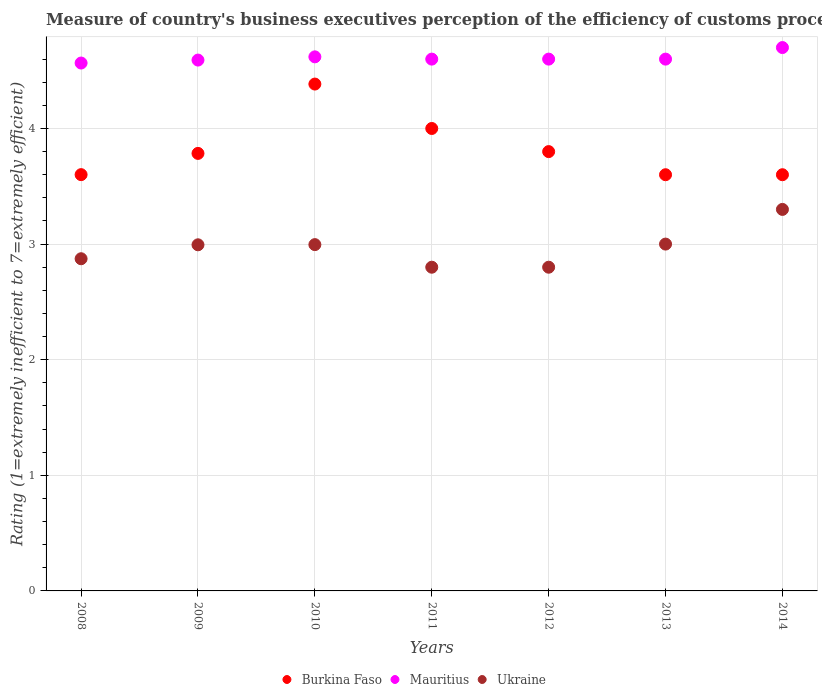Is the number of dotlines equal to the number of legend labels?
Your answer should be compact. Yes. Across all years, what is the maximum rating of the efficiency of customs procedure in Mauritius?
Your response must be concise. 4.7. In which year was the rating of the efficiency of customs procedure in Ukraine maximum?
Give a very brief answer. 2014. What is the total rating of the efficiency of customs procedure in Burkina Faso in the graph?
Offer a very short reply. 26.77. What is the difference between the rating of the efficiency of customs procedure in Mauritius in 2009 and that in 2012?
Keep it short and to the point. -0.01. What is the difference between the rating of the efficiency of customs procedure in Mauritius in 2011 and the rating of the efficiency of customs procedure in Ukraine in 2012?
Your answer should be compact. 1.8. What is the average rating of the efficiency of customs procedure in Ukraine per year?
Give a very brief answer. 2.97. In the year 2009, what is the difference between the rating of the efficiency of customs procedure in Mauritius and rating of the efficiency of customs procedure in Ukraine?
Provide a succinct answer. 1.6. What is the ratio of the rating of the efficiency of customs procedure in Ukraine in 2008 to that in 2014?
Your answer should be very brief. 0.87. What is the difference between the highest and the second highest rating of the efficiency of customs procedure in Burkina Faso?
Your answer should be very brief. 0.38. What is the difference between the highest and the lowest rating of the efficiency of customs procedure in Ukraine?
Give a very brief answer. 0.5. In how many years, is the rating of the efficiency of customs procedure in Burkina Faso greater than the average rating of the efficiency of customs procedure in Burkina Faso taken over all years?
Provide a short and direct response. 2. Is the rating of the efficiency of customs procedure in Ukraine strictly greater than the rating of the efficiency of customs procedure in Mauritius over the years?
Your answer should be compact. No. Is the rating of the efficiency of customs procedure in Ukraine strictly less than the rating of the efficiency of customs procedure in Mauritius over the years?
Your answer should be very brief. Yes. How many dotlines are there?
Make the answer very short. 3. How many years are there in the graph?
Offer a very short reply. 7. What is the difference between two consecutive major ticks on the Y-axis?
Offer a terse response. 1. Where does the legend appear in the graph?
Offer a very short reply. Bottom center. How many legend labels are there?
Offer a very short reply. 3. What is the title of the graph?
Give a very brief answer. Measure of country's business executives perception of the efficiency of customs procedures. Does "Pakistan" appear as one of the legend labels in the graph?
Provide a succinct answer. No. What is the label or title of the X-axis?
Ensure brevity in your answer.  Years. What is the label or title of the Y-axis?
Ensure brevity in your answer.  Rating (1=extremely inefficient to 7=extremely efficient). What is the Rating (1=extremely inefficient to 7=extremely efficient) of Burkina Faso in 2008?
Offer a very short reply. 3.6. What is the Rating (1=extremely inefficient to 7=extremely efficient) of Mauritius in 2008?
Your answer should be very brief. 4.57. What is the Rating (1=extremely inefficient to 7=extremely efficient) of Ukraine in 2008?
Provide a succinct answer. 2.87. What is the Rating (1=extremely inefficient to 7=extremely efficient) of Burkina Faso in 2009?
Your answer should be very brief. 3.78. What is the Rating (1=extremely inefficient to 7=extremely efficient) of Mauritius in 2009?
Your response must be concise. 4.59. What is the Rating (1=extremely inefficient to 7=extremely efficient) in Ukraine in 2009?
Your answer should be very brief. 2.99. What is the Rating (1=extremely inefficient to 7=extremely efficient) in Burkina Faso in 2010?
Offer a very short reply. 4.38. What is the Rating (1=extremely inefficient to 7=extremely efficient) in Mauritius in 2010?
Offer a very short reply. 4.62. What is the Rating (1=extremely inefficient to 7=extremely efficient) of Ukraine in 2010?
Provide a short and direct response. 3. What is the Rating (1=extremely inefficient to 7=extremely efficient) in Mauritius in 2011?
Give a very brief answer. 4.6. What is the Rating (1=extremely inefficient to 7=extremely efficient) in Ukraine in 2011?
Your response must be concise. 2.8. What is the Rating (1=extremely inefficient to 7=extremely efficient) of Mauritius in 2013?
Ensure brevity in your answer.  4.6. What is the Rating (1=extremely inefficient to 7=extremely efficient) in Burkina Faso in 2014?
Make the answer very short. 3.6. What is the Rating (1=extremely inefficient to 7=extremely efficient) of Mauritius in 2014?
Give a very brief answer. 4.7. Across all years, what is the maximum Rating (1=extremely inefficient to 7=extremely efficient) of Burkina Faso?
Your response must be concise. 4.38. Across all years, what is the maximum Rating (1=extremely inefficient to 7=extremely efficient) of Mauritius?
Provide a short and direct response. 4.7. Across all years, what is the maximum Rating (1=extremely inefficient to 7=extremely efficient) of Ukraine?
Ensure brevity in your answer.  3.3. Across all years, what is the minimum Rating (1=extremely inefficient to 7=extremely efficient) in Mauritius?
Provide a short and direct response. 4.57. Across all years, what is the minimum Rating (1=extremely inefficient to 7=extremely efficient) in Ukraine?
Keep it short and to the point. 2.8. What is the total Rating (1=extremely inefficient to 7=extremely efficient) of Burkina Faso in the graph?
Your answer should be very brief. 26.77. What is the total Rating (1=extremely inefficient to 7=extremely efficient) of Mauritius in the graph?
Ensure brevity in your answer.  32.28. What is the total Rating (1=extremely inefficient to 7=extremely efficient) in Ukraine in the graph?
Keep it short and to the point. 20.76. What is the difference between the Rating (1=extremely inefficient to 7=extremely efficient) of Burkina Faso in 2008 and that in 2009?
Provide a short and direct response. -0.18. What is the difference between the Rating (1=extremely inefficient to 7=extremely efficient) of Mauritius in 2008 and that in 2009?
Your answer should be compact. -0.03. What is the difference between the Rating (1=extremely inefficient to 7=extremely efficient) in Ukraine in 2008 and that in 2009?
Your response must be concise. -0.12. What is the difference between the Rating (1=extremely inefficient to 7=extremely efficient) of Burkina Faso in 2008 and that in 2010?
Your response must be concise. -0.78. What is the difference between the Rating (1=extremely inefficient to 7=extremely efficient) in Mauritius in 2008 and that in 2010?
Ensure brevity in your answer.  -0.05. What is the difference between the Rating (1=extremely inefficient to 7=extremely efficient) of Ukraine in 2008 and that in 2010?
Give a very brief answer. -0.12. What is the difference between the Rating (1=extremely inefficient to 7=extremely efficient) of Burkina Faso in 2008 and that in 2011?
Provide a succinct answer. -0.4. What is the difference between the Rating (1=extremely inefficient to 7=extremely efficient) in Mauritius in 2008 and that in 2011?
Keep it short and to the point. -0.03. What is the difference between the Rating (1=extremely inefficient to 7=extremely efficient) in Ukraine in 2008 and that in 2011?
Provide a succinct answer. 0.07. What is the difference between the Rating (1=extremely inefficient to 7=extremely efficient) of Burkina Faso in 2008 and that in 2012?
Offer a very short reply. -0.2. What is the difference between the Rating (1=extremely inefficient to 7=extremely efficient) of Mauritius in 2008 and that in 2012?
Offer a terse response. -0.03. What is the difference between the Rating (1=extremely inefficient to 7=extremely efficient) of Ukraine in 2008 and that in 2012?
Your response must be concise. 0.07. What is the difference between the Rating (1=extremely inefficient to 7=extremely efficient) of Burkina Faso in 2008 and that in 2013?
Your answer should be compact. 0. What is the difference between the Rating (1=extremely inefficient to 7=extremely efficient) of Mauritius in 2008 and that in 2013?
Keep it short and to the point. -0.03. What is the difference between the Rating (1=extremely inefficient to 7=extremely efficient) in Ukraine in 2008 and that in 2013?
Your answer should be compact. -0.13. What is the difference between the Rating (1=extremely inefficient to 7=extremely efficient) of Burkina Faso in 2008 and that in 2014?
Your answer should be compact. 0. What is the difference between the Rating (1=extremely inefficient to 7=extremely efficient) of Mauritius in 2008 and that in 2014?
Provide a short and direct response. -0.13. What is the difference between the Rating (1=extremely inefficient to 7=extremely efficient) of Ukraine in 2008 and that in 2014?
Your answer should be very brief. -0.43. What is the difference between the Rating (1=extremely inefficient to 7=extremely efficient) in Burkina Faso in 2009 and that in 2010?
Your response must be concise. -0.6. What is the difference between the Rating (1=extremely inefficient to 7=extremely efficient) of Mauritius in 2009 and that in 2010?
Your answer should be compact. -0.03. What is the difference between the Rating (1=extremely inefficient to 7=extremely efficient) of Ukraine in 2009 and that in 2010?
Ensure brevity in your answer.  -0. What is the difference between the Rating (1=extremely inefficient to 7=extremely efficient) of Burkina Faso in 2009 and that in 2011?
Your response must be concise. -0.22. What is the difference between the Rating (1=extremely inefficient to 7=extremely efficient) in Mauritius in 2009 and that in 2011?
Give a very brief answer. -0.01. What is the difference between the Rating (1=extremely inefficient to 7=extremely efficient) in Ukraine in 2009 and that in 2011?
Your response must be concise. 0.19. What is the difference between the Rating (1=extremely inefficient to 7=extremely efficient) in Burkina Faso in 2009 and that in 2012?
Keep it short and to the point. -0.02. What is the difference between the Rating (1=extremely inefficient to 7=extremely efficient) of Mauritius in 2009 and that in 2012?
Offer a terse response. -0.01. What is the difference between the Rating (1=extremely inefficient to 7=extremely efficient) of Ukraine in 2009 and that in 2012?
Offer a terse response. 0.19. What is the difference between the Rating (1=extremely inefficient to 7=extremely efficient) of Burkina Faso in 2009 and that in 2013?
Ensure brevity in your answer.  0.18. What is the difference between the Rating (1=extremely inefficient to 7=extremely efficient) in Mauritius in 2009 and that in 2013?
Provide a succinct answer. -0.01. What is the difference between the Rating (1=extremely inefficient to 7=extremely efficient) in Ukraine in 2009 and that in 2013?
Your response must be concise. -0.01. What is the difference between the Rating (1=extremely inefficient to 7=extremely efficient) of Burkina Faso in 2009 and that in 2014?
Offer a very short reply. 0.18. What is the difference between the Rating (1=extremely inefficient to 7=extremely efficient) of Mauritius in 2009 and that in 2014?
Your answer should be very brief. -0.11. What is the difference between the Rating (1=extremely inefficient to 7=extremely efficient) of Ukraine in 2009 and that in 2014?
Provide a succinct answer. -0.31. What is the difference between the Rating (1=extremely inefficient to 7=extremely efficient) of Burkina Faso in 2010 and that in 2011?
Offer a terse response. 0.38. What is the difference between the Rating (1=extremely inefficient to 7=extremely efficient) in Mauritius in 2010 and that in 2011?
Your response must be concise. 0.02. What is the difference between the Rating (1=extremely inefficient to 7=extremely efficient) in Ukraine in 2010 and that in 2011?
Keep it short and to the point. 0.2. What is the difference between the Rating (1=extremely inefficient to 7=extremely efficient) in Burkina Faso in 2010 and that in 2012?
Your response must be concise. 0.58. What is the difference between the Rating (1=extremely inefficient to 7=extremely efficient) in Mauritius in 2010 and that in 2012?
Keep it short and to the point. 0.02. What is the difference between the Rating (1=extremely inefficient to 7=extremely efficient) of Ukraine in 2010 and that in 2012?
Make the answer very short. 0.2. What is the difference between the Rating (1=extremely inefficient to 7=extremely efficient) in Burkina Faso in 2010 and that in 2013?
Provide a short and direct response. 0.78. What is the difference between the Rating (1=extremely inefficient to 7=extremely efficient) in Mauritius in 2010 and that in 2013?
Make the answer very short. 0.02. What is the difference between the Rating (1=extremely inefficient to 7=extremely efficient) of Ukraine in 2010 and that in 2013?
Offer a terse response. -0. What is the difference between the Rating (1=extremely inefficient to 7=extremely efficient) of Burkina Faso in 2010 and that in 2014?
Provide a short and direct response. 0.78. What is the difference between the Rating (1=extremely inefficient to 7=extremely efficient) of Mauritius in 2010 and that in 2014?
Provide a succinct answer. -0.08. What is the difference between the Rating (1=extremely inefficient to 7=extremely efficient) of Ukraine in 2010 and that in 2014?
Keep it short and to the point. -0.3. What is the difference between the Rating (1=extremely inefficient to 7=extremely efficient) in Mauritius in 2011 and that in 2012?
Your response must be concise. 0. What is the difference between the Rating (1=extremely inefficient to 7=extremely efficient) in Mauritius in 2011 and that in 2013?
Give a very brief answer. 0. What is the difference between the Rating (1=extremely inefficient to 7=extremely efficient) of Burkina Faso in 2012 and that in 2013?
Give a very brief answer. 0.2. What is the difference between the Rating (1=extremely inefficient to 7=extremely efficient) in Mauritius in 2012 and that in 2013?
Make the answer very short. 0. What is the difference between the Rating (1=extremely inefficient to 7=extremely efficient) in Ukraine in 2012 and that in 2013?
Give a very brief answer. -0.2. What is the difference between the Rating (1=extremely inefficient to 7=extremely efficient) in Burkina Faso in 2012 and that in 2014?
Offer a terse response. 0.2. What is the difference between the Rating (1=extremely inefficient to 7=extremely efficient) in Mauritius in 2012 and that in 2014?
Keep it short and to the point. -0.1. What is the difference between the Rating (1=extremely inefficient to 7=extremely efficient) in Burkina Faso in 2013 and that in 2014?
Make the answer very short. 0. What is the difference between the Rating (1=extremely inefficient to 7=extremely efficient) in Mauritius in 2013 and that in 2014?
Your answer should be compact. -0.1. What is the difference between the Rating (1=extremely inefficient to 7=extremely efficient) in Ukraine in 2013 and that in 2014?
Offer a terse response. -0.3. What is the difference between the Rating (1=extremely inefficient to 7=extremely efficient) in Burkina Faso in 2008 and the Rating (1=extremely inefficient to 7=extremely efficient) in Mauritius in 2009?
Provide a short and direct response. -0.99. What is the difference between the Rating (1=extremely inefficient to 7=extremely efficient) in Burkina Faso in 2008 and the Rating (1=extremely inefficient to 7=extremely efficient) in Ukraine in 2009?
Your answer should be very brief. 0.61. What is the difference between the Rating (1=extremely inefficient to 7=extremely efficient) of Mauritius in 2008 and the Rating (1=extremely inefficient to 7=extremely efficient) of Ukraine in 2009?
Offer a terse response. 1.57. What is the difference between the Rating (1=extremely inefficient to 7=extremely efficient) of Burkina Faso in 2008 and the Rating (1=extremely inefficient to 7=extremely efficient) of Mauritius in 2010?
Give a very brief answer. -1.02. What is the difference between the Rating (1=extremely inefficient to 7=extremely efficient) of Burkina Faso in 2008 and the Rating (1=extremely inefficient to 7=extremely efficient) of Ukraine in 2010?
Your response must be concise. 0.61. What is the difference between the Rating (1=extremely inefficient to 7=extremely efficient) of Mauritius in 2008 and the Rating (1=extremely inefficient to 7=extremely efficient) of Ukraine in 2010?
Keep it short and to the point. 1.57. What is the difference between the Rating (1=extremely inefficient to 7=extremely efficient) of Burkina Faso in 2008 and the Rating (1=extremely inefficient to 7=extremely efficient) of Mauritius in 2011?
Keep it short and to the point. -1. What is the difference between the Rating (1=extremely inefficient to 7=extremely efficient) of Burkina Faso in 2008 and the Rating (1=extremely inefficient to 7=extremely efficient) of Ukraine in 2011?
Your answer should be compact. 0.8. What is the difference between the Rating (1=extremely inefficient to 7=extremely efficient) in Mauritius in 2008 and the Rating (1=extremely inefficient to 7=extremely efficient) in Ukraine in 2011?
Offer a very short reply. 1.77. What is the difference between the Rating (1=extremely inefficient to 7=extremely efficient) in Burkina Faso in 2008 and the Rating (1=extremely inefficient to 7=extremely efficient) in Mauritius in 2012?
Give a very brief answer. -1. What is the difference between the Rating (1=extremely inefficient to 7=extremely efficient) of Burkina Faso in 2008 and the Rating (1=extremely inefficient to 7=extremely efficient) of Ukraine in 2012?
Offer a terse response. 0.8. What is the difference between the Rating (1=extremely inefficient to 7=extremely efficient) in Mauritius in 2008 and the Rating (1=extremely inefficient to 7=extremely efficient) in Ukraine in 2012?
Provide a short and direct response. 1.77. What is the difference between the Rating (1=extremely inefficient to 7=extremely efficient) in Burkina Faso in 2008 and the Rating (1=extremely inefficient to 7=extremely efficient) in Mauritius in 2013?
Give a very brief answer. -1. What is the difference between the Rating (1=extremely inefficient to 7=extremely efficient) of Burkina Faso in 2008 and the Rating (1=extremely inefficient to 7=extremely efficient) of Ukraine in 2013?
Provide a succinct answer. 0.6. What is the difference between the Rating (1=extremely inefficient to 7=extremely efficient) in Mauritius in 2008 and the Rating (1=extremely inefficient to 7=extremely efficient) in Ukraine in 2013?
Offer a terse response. 1.57. What is the difference between the Rating (1=extremely inefficient to 7=extremely efficient) in Burkina Faso in 2008 and the Rating (1=extremely inefficient to 7=extremely efficient) in Mauritius in 2014?
Offer a terse response. -1.1. What is the difference between the Rating (1=extremely inefficient to 7=extremely efficient) in Burkina Faso in 2008 and the Rating (1=extremely inefficient to 7=extremely efficient) in Ukraine in 2014?
Give a very brief answer. 0.3. What is the difference between the Rating (1=extremely inefficient to 7=extremely efficient) in Mauritius in 2008 and the Rating (1=extremely inefficient to 7=extremely efficient) in Ukraine in 2014?
Provide a succinct answer. 1.27. What is the difference between the Rating (1=extremely inefficient to 7=extremely efficient) of Burkina Faso in 2009 and the Rating (1=extremely inefficient to 7=extremely efficient) of Mauritius in 2010?
Ensure brevity in your answer.  -0.84. What is the difference between the Rating (1=extremely inefficient to 7=extremely efficient) in Burkina Faso in 2009 and the Rating (1=extremely inefficient to 7=extremely efficient) in Ukraine in 2010?
Make the answer very short. 0.79. What is the difference between the Rating (1=extremely inefficient to 7=extremely efficient) in Mauritius in 2009 and the Rating (1=extremely inefficient to 7=extremely efficient) in Ukraine in 2010?
Provide a succinct answer. 1.6. What is the difference between the Rating (1=extremely inefficient to 7=extremely efficient) of Burkina Faso in 2009 and the Rating (1=extremely inefficient to 7=extremely efficient) of Mauritius in 2011?
Your answer should be compact. -0.82. What is the difference between the Rating (1=extremely inefficient to 7=extremely efficient) of Burkina Faso in 2009 and the Rating (1=extremely inefficient to 7=extremely efficient) of Ukraine in 2011?
Your answer should be very brief. 0.98. What is the difference between the Rating (1=extremely inefficient to 7=extremely efficient) of Mauritius in 2009 and the Rating (1=extremely inefficient to 7=extremely efficient) of Ukraine in 2011?
Give a very brief answer. 1.79. What is the difference between the Rating (1=extremely inefficient to 7=extremely efficient) in Burkina Faso in 2009 and the Rating (1=extremely inefficient to 7=extremely efficient) in Mauritius in 2012?
Your answer should be compact. -0.82. What is the difference between the Rating (1=extremely inefficient to 7=extremely efficient) of Burkina Faso in 2009 and the Rating (1=extremely inefficient to 7=extremely efficient) of Ukraine in 2012?
Your response must be concise. 0.98. What is the difference between the Rating (1=extremely inefficient to 7=extremely efficient) in Mauritius in 2009 and the Rating (1=extremely inefficient to 7=extremely efficient) in Ukraine in 2012?
Your response must be concise. 1.79. What is the difference between the Rating (1=extremely inefficient to 7=extremely efficient) of Burkina Faso in 2009 and the Rating (1=extremely inefficient to 7=extremely efficient) of Mauritius in 2013?
Keep it short and to the point. -0.82. What is the difference between the Rating (1=extremely inefficient to 7=extremely efficient) of Burkina Faso in 2009 and the Rating (1=extremely inefficient to 7=extremely efficient) of Ukraine in 2013?
Your response must be concise. 0.78. What is the difference between the Rating (1=extremely inefficient to 7=extremely efficient) in Mauritius in 2009 and the Rating (1=extremely inefficient to 7=extremely efficient) in Ukraine in 2013?
Keep it short and to the point. 1.59. What is the difference between the Rating (1=extremely inefficient to 7=extremely efficient) of Burkina Faso in 2009 and the Rating (1=extremely inefficient to 7=extremely efficient) of Mauritius in 2014?
Your response must be concise. -0.92. What is the difference between the Rating (1=extremely inefficient to 7=extremely efficient) in Burkina Faso in 2009 and the Rating (1=extremely inefficient to 7=extremely efficient) in Ukraine in 2014?
Give a very brief answer. 0.48. What is the difference between the Rating (1=extremely inefficient to 7=extremely efficient) of Mauritius in 2009 and the Rating (1=extremely inefficient to 7=extremely efficient) of Ukraine in 2014?
Your answer should be compact. 1.29. What is the difference between the Rating (1=extremely inefficient to 7=extremely efficient) in Burkina Faso in 2010 and the Rating (1=extremely inefficient to 7=extremely efficient) in Mauritius in 2011?
Offer a very short reply. -0.22. What is the difference between the Rating (1=extremely inefficient to 7=extremely efficient) in Burkina Faso in 2010 and the Rating (1=extremely inefficient to 7=extremely efficient) in Ukraine in 2011?
Ensure brevity in your answer.  1.58. What is the difference between the Rating (1=extremely inefficient to 7=extremely efficient) in Mauritius in 2010 and the Rating (1=extremely inefficient to 7=extremely efficient) in Ukraine in 2011?
Give a very brief answer. 1.82. What is the difference between the Rating (1=extremely inefficient to 7=extremely efficient) of Burkina Faso in 2010 and the Rating (1=extremely inefficient to 7=extremely efficient) of Mauritius in 2012?
Provide a short and direct response. -0.22. What is the difference between the Rating (1=extremely inefficient to 7=extremely efficient) of Burkina Faso in 2010 and the Rating (1=extremely inefficient to 7=extremely efficient) of Ukraine in 2012?
Keep it short and to the point. 1.58. What is the difference between the Rating (1=extremely inefficient to 7=extremely efficient) in Mauritius in 2010 and the Rating (1=extremely inefficient to 7=extremely efficient) in Ukraine in 2012?
Your response must be concise. 1.82. What is the difference between the Rating (1=extremely inefficient to 7=extremely efficient) of Burkina Faso in 2010 and the Rating (1=extremely inefficient to 7=extremely efficient) of Mauritius in 2013?
Provide a succinct answer. -0.22. What is the difference between the Rating (1=extremely inefficient to 7=extremely efficient) in Burkina Faso in 2010 and the Rating (1=extremely inefficient to 7=extremely efficient) in Ukraine in 2013?
Give a very brief answer. 1.38. What is the difference between the Rating (1=extremely inefficient to 7=extremely efficient) in Mauritius in 2010 and the Rating (1=extremely inefficient to 7=extremely efficient) in Ukraine in 2013?
Offer a terse response. 1.62. What is the difference between the Rating (1=extremely inefficient to 7=extremely efficient) in Burkina Faso in 2010 and the Rating (1=extremely inefficient to 7=extremely efficient) in Mauritius in 2014?
Keep it short and to the point. -0.32. What is the difference between the Rating (1=extremely inefficient to 7=extremely efficient) of Burkina Faso in 2010 and the Rating (1=extremely inefficient to 7=extremely efficient) of Ukraine in 2014?
Your answer should be compact. 1.08. What is the difference between the Rating (1=extremely inefficient to 7=extremely efficient) of Mauritius in 2010 and the Rating (1=extremely inefficient to 7=extremely efficient) of Ukraine in 2014?
Your response must be concise. 1.32. What is the difference between the Rating (1=extremely inefficient to 7=extremely efficient) of Burkina Faso in 2011 and the Rating (1=extremely inefficient to 7=extremely efficient) of Mauritius in 2012?
Offer a very short reply. -0.6. What is the difference between the Rating (1=extremely inefficient to 7=extremely efficient) in Mauritius in 2011 and the Rating (1=extremely inefficient to 7=extremely efficient) in Ukraine in 2012?
Ensure brevity in your answer.  1.8. What is the difference between the Rating (1=extremely inefficient to 7=extremely efficient) in Burkina Faso in 2011 and the Rating (1=extremely inefficient to 7=extremely efficient) in Ukraine in 2014?
Offer a very short reply. 0.7. What is the difference between the Rating (1=extremely inefficient to 7=extremely efficient) of Burkina Faso in 2012 and the Rating (1=extremely inefficient to 7=extremely efficient) of Ukraine in 2013?
Your answer should be compact. 0.8. What is the difference between the Rating (1=extremely inefficient to 7=extremely efficient) in Burkina Faso in 2012 and the Rating (1=extremely inefficient to 7=extremely efficient) in Ukraine in 2014?
Provide a succinct answer. 0.5. What is the difference between the Rating (1=extremely inefficient to 7=extremely efficient) in Mauritius in 2012 and the Rating (1=extremely inefficient to 7=extremely efficient) in Ukraine in 2014?
Ensure brevity in your answer.  1.3. What is the difference between the Rating (1=extremely inefficient to 7=extremely efficient) of Burkina Faso in 2013 and the Rating (1=extremely inefficient to 7=extremely efficient) of Mauritius in 2014?
Offer a terse response. -1.1. What is the difference between the Rating (1=extremely inefficient to 7=extremely efficient) in Burkina Faso in 2013 and the Rating (1=extremely inefficient to 7=extremely efficient) in Ukraine in 2014?
Your answer should be very brief. 0.3. What is the average Rating (1=extremely inefficient to 7=extremely efficient) in Burkina Faso per year?
Keep it short and to the point. 3.82. What is the average Rating (1=extremely inefficient to 7=extremely efficient) in Mauritius per year?
Offer a very short reply. 4.61. What is the average Rating (1=extremely inefficient to 7=extremely efficient) of Ukraine per year?
Give a very brief answer. 2.97. In the year 2008, what is the difference between the Rating (1=extremely inefficient to 7=extremely efficient) in Burkina Faso and Rating (1=extremely inefficient to 7=extremely efficient) in Mauritius?
Provide a short and direct response. -0.97. In the year 2008, what is the difference between the Rating (1=extremely inefficient to 7=extremely efficient) in Burkina Faso and Rating (1=extremely inefficient to 7=extremely efficient) in Ukraine?
Your answer should be very brief. 0.73. In the year 2008, what is the difference between the Rating (1=extremely inefficient to 7=extremely efficient) in Mauritius and Rating (1=extremely inefficient to 7=extremely efficient) in Ukraine?
Make the answer very short. 1.69. In the year 2009, what is the difference between the Rating (1=extremely inefficient to 7=extremely efficient) in Burkina Faso and Rating (1=extremely inefficient to 7=extremely efficient) in Mauritius?
Your response must be concise. -0.81. In the year 2009, what is the difference between the Rating (1=extremely inefficient to 7=extremely efficient) in Burkina Faso and Rating (1=extremely inefficient to 7=extremely efficient) in Ukraine?
Give a very brief answer. 0.79. In the year 2009, what is the difference between the Rating (1=extremely inefficient to 7=extremely efficient) of Mauritius and Rating (1=extremely inefficient to 7=extremely efficient) of Ukraine?
Your response must be concise. 1.6. In the year 2010, what is the difference between the Rating (1=extremely inefficient to 7=extremely efficient) in Burkina Faso and Rating (1=extremely inefficient to 7=extremely efficient) in Mauritius?
Provide a succinct answer. -0.24. In the year 2010, what is the difference between the Rating (1=extremely inefficient to 7=extremely efficient) of Burkina Faso and Rating (1=extremely inefficient to 7=extremely efficient) of Ukraine?
Provide a succinct answer. 1.39. In the year 2010, what is the difference between the Rating (1=extremely inefficient to 7=extremely efficient) of Mauritius and Rating (1=extremely inefficient to 7=extremely efficient) of Ukraine?
Your answer should be compact. 1.62. In the year 2011, what is the difference between the Rating (1=extremely inefficient to 7=extremely efficient) of Mauritius and Rating (1=extremely inefficient to 7=extremely efficient) of Ukraine?
Your answer should be compact. 1.8. In the year 2012, what is the difference between the Rating (1=extremely inefficient to 7=extremely efficient) of Burkina Faso and Rating (1=extremely inefficient to 7=extremely efficient) of Ukraine?
Ensure brevity in your answer.  1. In the year 2012, what is the difference between the Rating (1=extremely inefficient to 7=extremely efficient) of Mauritius and Rating (1=extremely inefficient to 7=extremely efficient) of Ukraine?
Provide a succinct answer. 1.8. In the year 2013, what is the difference between the Rating (1=extremely inefficient to 7=extremely efficient) of Mauritius and Rating (1=extremely inefficient to 7=extremely efficient) of Ukraine?
Your response must be concise. 1.6. In the year 2014, what is the difference between the Rating (1=extremely inefficient to 7=extremely efficient) in Burkina Faso and Rating (1=extremely inefficient to 7=extremely efficient) in Ukraine?
Provide a succinct answer. 0.3. What is the ratio of the Rating (1=extremely inefficient to 7=extremely efficient) of Burkina Faso in 2008 to that in 2009?
Your answer should be compact. 0.95. What is the ratio of the Rating (1=extremely inefficient to 7=extremely efficient) of Mauritius in 2008 to that in 2009?
Keep it short and to the point. 0.99. What is the ratio of the Rating (1=extremely inefficient to 7=extremely efficient) of Ukraine in 2008 to that in 2009?
Your answer should be compact. 0.96. What is the ratio of the Rating (1=extremely inefficient to 7=extremely efficient) of Burkina Faso in 2008 to that in 2010?
Your answer should be compact. 0.82. What is the ratio of the Rating (1=extremely inefficient to 7=extremely efficient) of Mauritius in 2008 to that in 2010?
Make the answer very short. 0.99. What is the ratio of the Rating (1=extremely inefficient to 7=extremely efficient) of Ukraine in 2008 to that in 2010?
Ensure brevity in your answer.  0.96. What is the ratio of the Rating (1=extremely inefficient to 7=extremely efficient) in Burkina Faso in 2008 to that in 2011?
Offer a terse response. 0.9. What is the ratio of the Rating (1=extremely inefficient to 7=extremely efficient) in Ukraine in 2008 to that in 2011?
Provide a succinct answer. 1.03. What is the ratio of the Rating (1=extremely inefficient to 7=extremely efficient) in Burkina Faso in 2008 to that in 2012?
Offer a very short reply. 0.95. What is the ratio of the Rating (1=extremely inefficient to 7=extremely efficient) of Mauritius in 2008 to that in 2012?
Make the answer very short. 0.99. What is the ratio of the Rating (1=extremely inefficient to 7=extremely efficient) in Ukraine in 2008 to that in 2012?
Your answer should be very brief. 1.03. What is the ratio of the Rating (1=extremely inefficient to 7=extremely efficient) of Burkina Faso in 2008 to that in 2013?
Your answer should be very brief. 1. What is the ratio of the Rating (1=extremely inefficient to 7=extremely efficient) of Mauritius in 2008 to that in 2013?
Offer a very short reply. 0.99. What is the ratio of the Rating (1=extremely inefficient to 7=extremely efficient) of Ukraine in 2008 to that in 2013?
Your answer should be very brief. 0.96. What is the ratio of the Rating (1=extremely inefficient to 7=extremely efficient) of Burkina Faso in 2008 to that in 2014?
Your answer should be compact. 1. What is the ratio of the Rating (1=extremely inefficient to 7=extremely efficient) in Mauritius in 2008 to that in 2014?
Keep it short and to the point. 0.97. What is the ratio of the Rating (1=extremely inefficient to 7=extremely efficient) in Ukraine in 2008 to that in 2014?
Offer a terse response. 0.87. What is the ratio of the Rating (1=extremely inefficient to 7=extremely efficient) of Burkina Faso in 2009 to that in 2010?
Provide a succinct answer. 0.86. What is the ratio of the Rating (1=extremely inefficient to 7=extremely efficient) of Ukraine in 2009 to that in 2010?
Offer a very short reply. 1. What is the ratio of the Rating (1=extremely inefficient to 7=extremely efficient) in Burkina Faso in 2009 to that in 2011?
Keep it short and to the point. 0.95. What is the ratio of the Rating (1=extremely inefficient to 7=extremely efficient) in Ukraine in 2009 to that in 2011?
Provide a short and direct response. 1.07. What is the ratio of the Rating (1=extremely inefficient to 7=extremely efficient) of Mauritius in 2009 to that in 2012?
Ensure brevity in your answer.  1. What is the ratio of the Rating (1=extremely inefficient to 7=extremely efficient) of Ukraine in 2009 to that in 2012?
Your answer should be compact. 1.07. What is the ratio of the Rating (1=extremely inefficient to 7=extremely efficient) of Burkina Faso in 2009 to that in 2013?
Ensure brevity in your answer.  1.05. What is the ratio of the Rating (1=extremely inefficient to 7=extremely efficient) of Burkina Faso in 2009 to that in 2014?
Your answer should be very brief. 1.05. What is the ratio of the Rating (1=extremely inefficient to 7=extremely efficient) of Mauritius in 2009 to that in 2014?
Keep it short and to the point. 0.98. What is the ratio of the Rating (1=extremely inefficient to 7=extremely efficient) of Ukraine in 2009 to that in 2014?
Provide a short and direct response. 0.91. What is the ratio of the Rating (1=extremely inefficient to 7=extremely efficient) of Burkina Faso in 2010 to that in 2011?
Make the answer very short. 1.1. What is the ratio of the Rating (1=extremely inefficient to 7=extremely efficient) of Mauritius in 2010 to that in 2011?
Your answer should be very brief. 1. What is the ratio of the Rating (1=extremely inefficient to 7=extremely efficient) of Ukraine in 2010 to that in 2011?
Give a very brief answer. 1.07. What is the ratio of the Rating (1=extremely inefficient to 7=extremely efficient) of Burkina Faso in 2010 to that in 2012?
Make the answer very short. 1.15. What is the ratio of the Rating (1=extremely inefficient to 7=extremely efficient) in Ukraine in 2010 to that in 2012?
Offer a terse response. 1.07. What is the ratio of the Rating (1=extremely inefficient to 7=extremely efficient) of Burkina Faso in 2010 to that in 2013?
Give a very brief answer. 1.22. What is the ratio of the Rating (1=extremely inefficient to 7=extremely efficient) of Burkina Faso in 2010 to that in 2014?
Offer a terse response. 1.22. What is the ratio of the Rating (1=extremely inefficient to 7=extremely efficient) in Mauritius in 2010 to that in 2014?
Provide a succinct answer. 0.98. What is the ratio of the Rating (1=extremely inefficient to 7=extremely efficient) in Ukraine in 2010 to that in 2014?
Offer a terse response. 0.91. What is the ratio of the Rating (1=extremely inefficient to 7=extremely efficient) in Burkina Faso in 2011 to that in 2012?
Offer a very short reply. 1.05. What is the ratio of the Rating (1=extremely inefficient to 7=extremely efficient) in Ukraine in 2011 to that in 2012?
Provide a short and direct response. 1. What is the ratio of the Rating (1=extremely inefficient to 7=extremely efficient) in Ukraine in 2011 to that in 2013?
Give a very brief answer. 0.93. What is the ratio of the Rating (1=extremely inefficient to 7=extremely efficient) of Burkina Faso in 2011 to that in 2014?
Your answer should be very brief. 1.11. What is the ratio of the Rating (1=extremely inefficient to 7=extremely efficient) in Mauritius in 2011 to that in 2014?
Offer a very short reply. 0.98. What is the ratio of the Rating (1=extremely inefficient to 7=extremely efficient) in Ukraine in 2011 to that in 2014?
Offer a terse response. 0.85. What is the ratio of the Rating (1=extremely inefficient to 7=extremely efficient) of Burkina Faso in 2012 to that in 2013?
Keep it short and to the point. 1.06. What is the ratio of the Rating (1=extremely inefficient to 7=extremely efficient) of Mauritius in 2012 to that in 2013?
Ensure brevity in your answer.  1. What is the ratio of the Rating (1=extremely inefficient to 7=extremely efficient) in Ukraine in 2012 to that in 2013?
Provide a short and direct response. 0.93. What is the ratio of the Rating (1=extremely inefficient to 7=extremely efficient) of Burkina Faso in 2012 to that in 2014?
Your answer should be very brief. 1.06. What is the ratio of the Rating (1=extremely inefficient to 7=extremely efficient) in Mauritius in 2012 to that in 2014?
Keep it short and to the point. 0.98. What is the ratio of the Rating (1=extremely inefficient to 7=extremely efficient) of Ukraine in 2012 to that in 2014?
Your answer should be compact. 0.85. What is the ratio of the Rating (1=extremely inefficient to 7=extremely efficient) of Burkina Faso in 2013 to that in 2014?
Offer a very short reply. 1. What is the ratio of the Rating (1=extremely inefficient to 7=extremely efficient) in Mauritius in 2013 to that in 2014?
Offer a very short reply. 0.98. What is the difference between the highest and the second highest Rating (1=extremely inefficient to 7=extremely efficient) in Burkina Faso?
Ensure brevity in your answer.  0.38. What is the difference between the highest and the second highest Rating (1=extremely inefficient to 7=extremely efficient) in Mauritius?
Your answer should be very brief. 0.08. What is the difference between the highest and the second highest Rating (1=extremely inefficient to 7=extremely efficient) of Ukraine?
Keep it short and to the point. 0.3. What is the difference between the highest and the lowest Rating (1=extremely inefficient to 7=extremely efficient) of Burkina Faso?
Make the answer very short. 0.78. What is the difference between the highest and the lowest Rating (1=extremely inefficient to 7=extremely efficient) of Mauritius?
Keep it short and to the point. 0.13. 